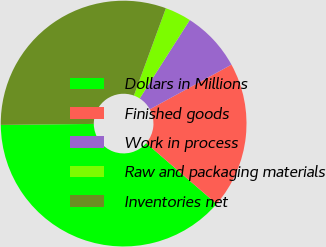Convert chart. <chart><loc_0><loc_0><loc_500><loc_500><pie_chart><fcel>Dollars in Millions<fcel>Finished goods<fcel>Work in process<fcel>Raw and packaging materials<fcel>Inventories net<nl><fcel>38.48%<fcel>19.31%<fcel>7.99%<fcel>3.46%<fcel>30.76%<nl></chart> 